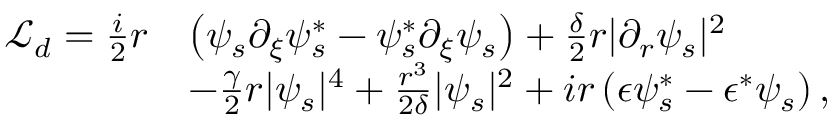<formula> <loc_0><loc_0><loc_500><loc_500>\begin{array} { r l } { \mathcal { L } _ { d } = \frac { i } { 2 } r } & { \left ( \psi _ { s } \partial _ { \xi } \psi _ { s } ^ { * } - \psi _ { s } ^ { * } \partial _ { \xi } \psi _ { s } \right ) + \frac { \delta } { 2 } r | \partial _ { r } \psi _ { s } | ^ { 2 } } \\ & { - \frac { \gamma } { 2 } r | \psi _ { s } | ^ { 4 } + \frac { r ^ { 3 } } { 2 \delta } | \psi _ { s } | ^ { 2 } + i r \left ( \epsilon \psi _ { s } ^ { * } - \epsilon ^ { * } \psi _ { s } \right ) , } \end{array}</formula> 